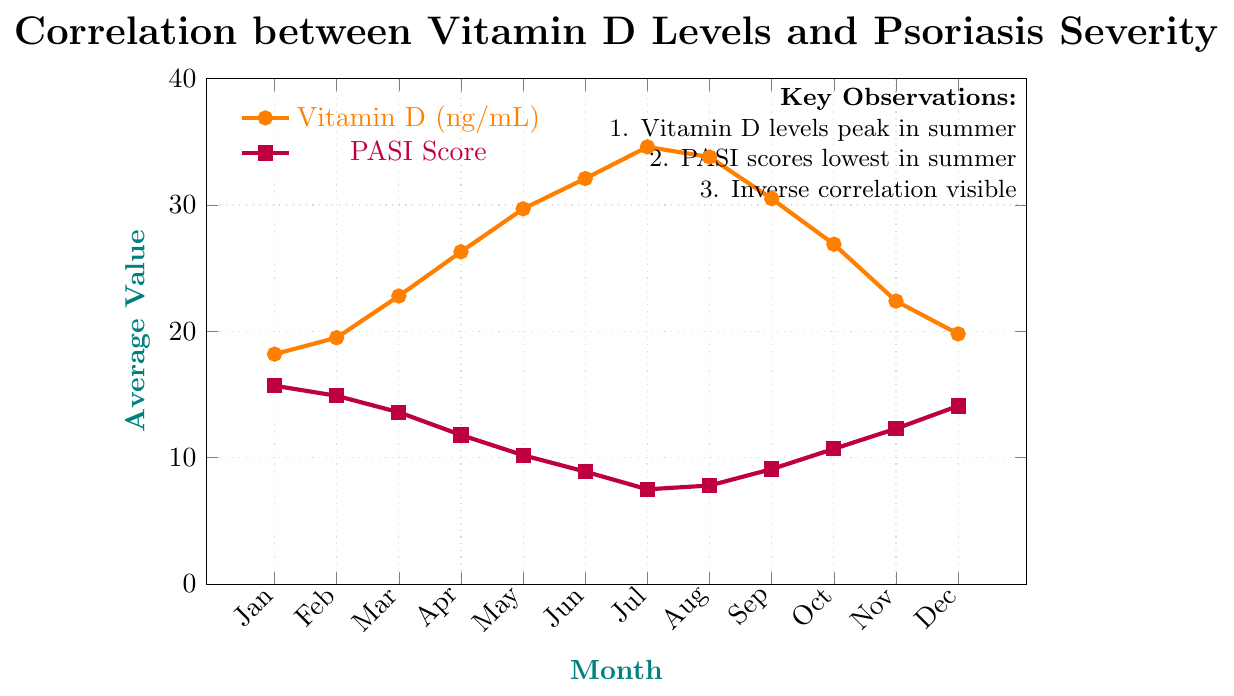What is the average Vitamin D level in the first half of the year (January - June)? To find the average Vitamin D level for the first half of the year, sum up the values for January to June (18.2 + 19.5 + 22.8 + 26.3 + 29.7 + 32.1) and divide by 6. The sum is 148.6; therefore, the average is 148.6 / 6 = 24.77 ng/mL.
Answer: 24.77 ng/mL In which month are the Vitamin D levels at their highest, and what is the corresponding PASI score? From the chart, Vitamin D levels are highest in July at 34.6 ng/mL. The corresponding PASI score for July is 7.5.
Answer: July, 7.5 Compare the Vitamin D levels between January and December. By how much do they differ? The Vitamin D level in January is 18.2 ng/mL, and in December it is 19.8 ng/mL. The difference is 19.8 - 18.2 = 1.6 ng/mL.
Answer: 1.6 ng/mL Which month shows the lowest PASI score and what is the value? From the chart, the PASI score is lowest in July with a value of 7.5.
Answer: July, 7.5 Describe the trend of the PASI score from June to October. The PASI score decreases steadily from June (8.9) to July (7.5), then slightly increases in August (7.8), and continues to rise in September (9.1) and October (10.7).
Answer: Decreasing from June to July, slight increase in August, rising again in September and October Is there any month where the PASI score and Vitamin D level both increase compared to the previous month? From the chart, in August, both the PASI score and Vitamin D level show an increase compared to July. The PASI score increases from 7.5 to 7.8, and the Vitamin D level decreases from 34.6 to 33.8, thus there is no month that fits this condition.
Answer: No What is the PASI score for May? How does it compare to June? The PASI score for May is 10.2, and for June it is 8.9. The PASI score decreases by 10.2 - 8.9 = 1.3 from May to June.
Answer: 10.2, decreased by 1.3 What is the overall trend in Vitamin D levels from January to December? The Vitamin D levels increase from January (18.2 ng/mL) to a peak in July (34.6 ng/mL) and then decrease to December (19.8 ng/mL).
Answer: Increase to July, then decrease By how much does the PASI score decrease from its highest point to its lowest? The highest PASI score is in January (15.7) and the lowest is in July (7.5). The decrease is 15.7 - 7.5 = 8.2.
Answer: 8.2 What observation can be made about the relationship between Vitamin D levels and PASI scores? From the chart, as Vitamin D levels increase, PASI scores tend to decrease, indicating an inverse correlation between Vitamin D levels and psoriasis severity.
Answer: Inverse correlation 